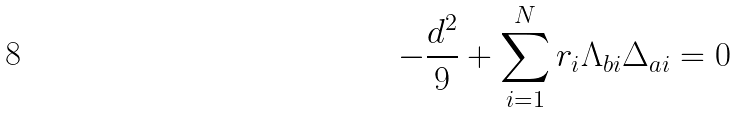<formula> <loc_0><loc_0><loc_500><loc_500>- \frac { d ^ { 2 } } { 9 } + \sum _ { i = 1 } ^ { N } r _ { i } \Lambda _ { b i } \Delta _ { a i } = 0</formula> 